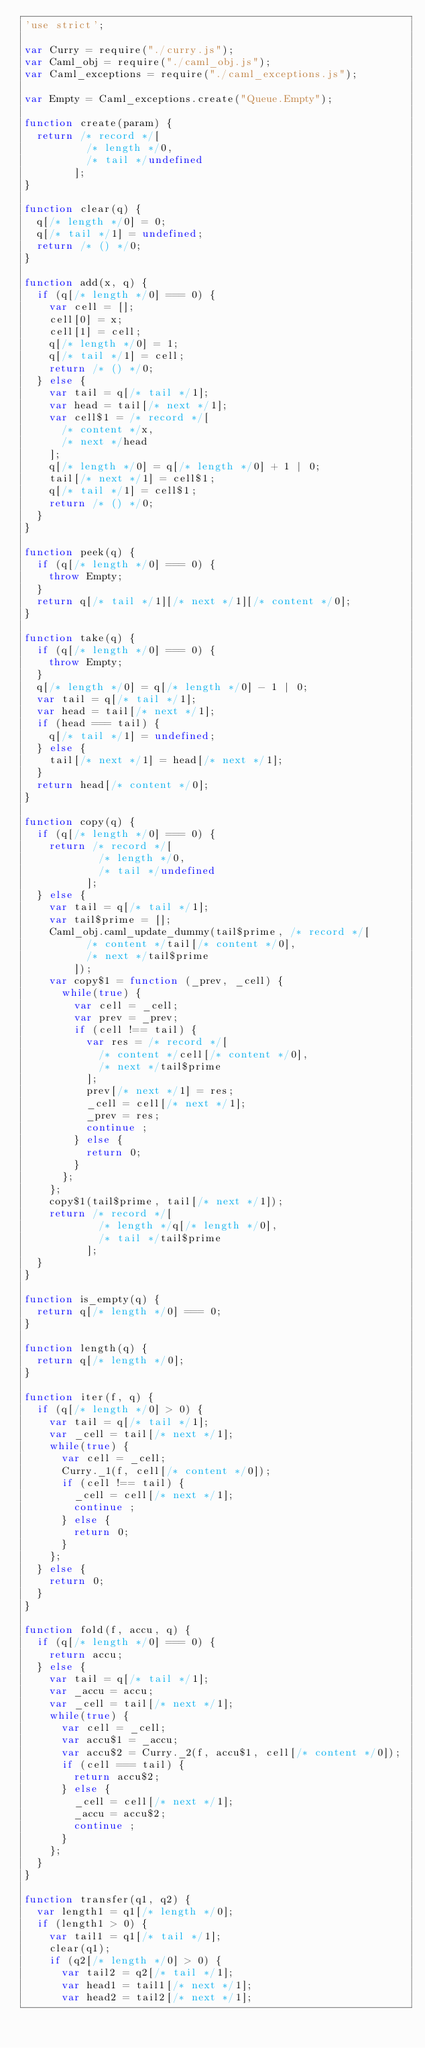<code> <loc_0><loc_0><loc_500><loc_500><_JavaScript_>'use strict';

var Curry = require("./curry.js");
var Caml_obj = require("./caml_obj.js");
var Caml_exceptions = require("./caml_exceptions.js");

var Empty = Caml_exceptions.create("Queue.Empty");

function create(param) {
  return /* record */[
          /* length */0,
          /* tail */undefined
        ];
}

function clear(q) {
  q[/* length */0] = 0;
  q[/* tail */1] = undefined;
  return /* () */0;
}

function add(x, q) {
  if (q[/* length */0] === 0) {
    var cell = [];
    cell[0] = x;
    cell[1] = cell;
    q[/* length */0] = 1;
    q[/* tail */1] = cell;
    return /* () */0;
  } else {
    var tail = q[/* tail */1];
    var head = tail[/* next */1];
    var cell$1 = /* record */[
      /* content */x,
      /* next */head
    ];
    q[/* length */0] = q[/* length */0] + 1 | 0;
    tail[/* next */1] = cell$1;
    q[/* tail */1] = cell$1;
    return /* () */0;
  }
}

function peek(q) {
  if (q[/* length */0] === 0) {
    throw Empty;
  }
  return q[/* tail */1][/* next */1][/* content */0];
}

function take(q) {
  if (q[/* length */0] === 0) {
    throw Empty;
  }
  q[/* length */0] = q[/* length */0] - 1 | 0;
  var tail = q[/* tail */1];
  var head = tail[/* next */1];
  if (head === tail) {
    q[/* tail */1] = undefined;
  } else {
    tail[/* next */1] = head[/* next */1];
  }
  return head[/* content */0];
}

function copy(q) {
  if (q[/* length */0] === 0) {
    return /* record */[
            /* length */0,
            /* tail */undefined
          ];
  } else {
    var tail = q[/* tail */1];
    var tail$prime = [];
    Caml_obj.caml_update_dummy(tail$prime, /* record */[
          /* content */tail[/* content */0],
          /* next */tail$prime
        ]);
    var copy$1 = function (_prev, _cell) {
      while(true) {
        var cell = _cell;
        var prev = _prev;
        if (cell !== tail) {
          var res = /* record */[
            /* content */cell[/* content */0],
            /* next */tail$prime
          ];
          prev[/* next */1] = res;
          _cell = cell[/* next */1];
          _prev = res;
          continue ;
        } else {
          return 0;
        }
      };
    };
    copy$1(tail$prime, tail[/* next */1]);
    return /* record */[
            /* length */q[/* length */0],
            /* tail */tail$prime
          ];
  }
}

function is_empty(q) {
  return q[/* length */0] === 0;
}

function length(q) {
  return q[/* length */0];
}

function iter(f, q) {
  if (q[/* length */0] > 0) {
    var tail = q[/* tail */1];
    var _cell = tail[/* next */1];
    while(true) {
      var cell = _cell;
      Curry._1(f, cell[/* content */0]);
      if (cell !== tail) {
        _cell = cell[/* next */1];
        continue ;
      } else {
        return 0;
      }
    };
  } else {
    return 0;
  }
}

function fold(f, accu, q) {
  if (q[/* length */0] === 0) {
    return accu;
  } else {
    var tail = q[/* tail */1];
    var _accu = accu;
    var _cell = tail[/* next */1];
    while(true) {
      var cell = _cell;
      var accu$1 = _accu;
      var accu$2 = Curry._2(f, accu$1, cell[/* content */0]);
      if (cell === tail) {
        return accu$2;
      } else {
        _cell = cell[/* next */1];
        _accu = accu$2;
        continue ;
      }
    };
  }
}

function transfer(q1, q2) {
  var length1 = q1[/* length */0];
  if (length1 > 0) {
    var tail1 = q1[/* tail */1];
    clear(q1);
    if (q2[/* length */0] > 0) {
      var tail2 = q2[/* tail */1];
      var head1 = tail1[/* next */1];
      var head2 = tail2[/* next */1];</code> 